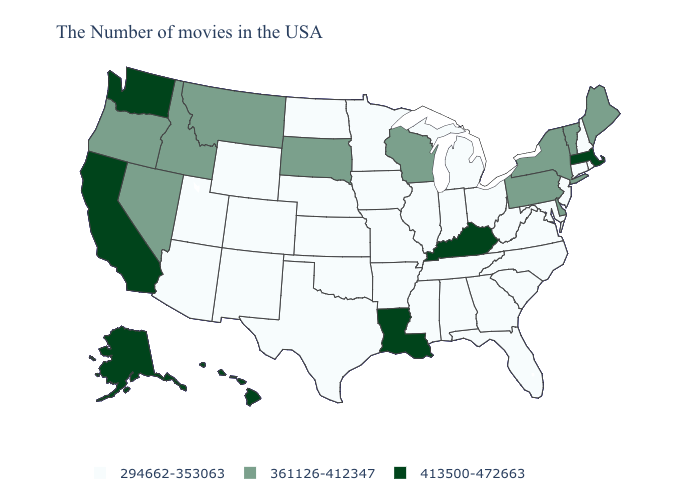Which states have the lowest value in the South?
Answer briefly. Maryland, Virginia, North Carolina, South Carolina, West Virginia, Florida, Georgia, Alabama, Tennessee, Mississippi, Arkansas, Oklahoma, Texas. Name the states that have a value in the range 413500-472663?
Keep it brief. Massachusetts, Kentucky, Louisiana, California, Washington, Alaska, Hawaii. Does Ohio have a lower value than New Mexico?
Concise answer only. No. What is the lowest value in the USA?
Be succinct. 294662-353063. Name the states that have a value in the range 361126-412347?
Write a very short answer. Maine, Vermont, New York, Delaware, Pennsylvania, Wisconsin, South Dakota, Montana, Idaho, Nevada, Oregon. What is the lowest value in the USA?
Give a very brief answer. 294662-353063. What is the value of Wyoming?
Be succinct. 294662-353063. Which states have the highest value in the USA?
Write a very short answer. Massachusetts, Kentucky, Louisiana, California, Washington, Alaska, Hawaii. Which states have the lowest value in the Northeast?
Give a very brief answer. Rhode Island, New Hampshire, Connecticut, New Jersey. How many symbols are there in the legend?
Give a very brief answer. 3. What is the value of South Dakota?
Concise answer only. 361126-412347. Does the first symbol in the legend represent the smallest category?
Be succinct. Yes. Which states have the lowest value in the Northeast?
Give a very brief answer. Rhode Island, New Hampshire, Connecticut, New Jersey. Name the states that have a value in the range 413500-472663?
Keep it brief. Massachusetts, Kentucky, Louisiana, California, Washington, Alaska, Hawaii. 